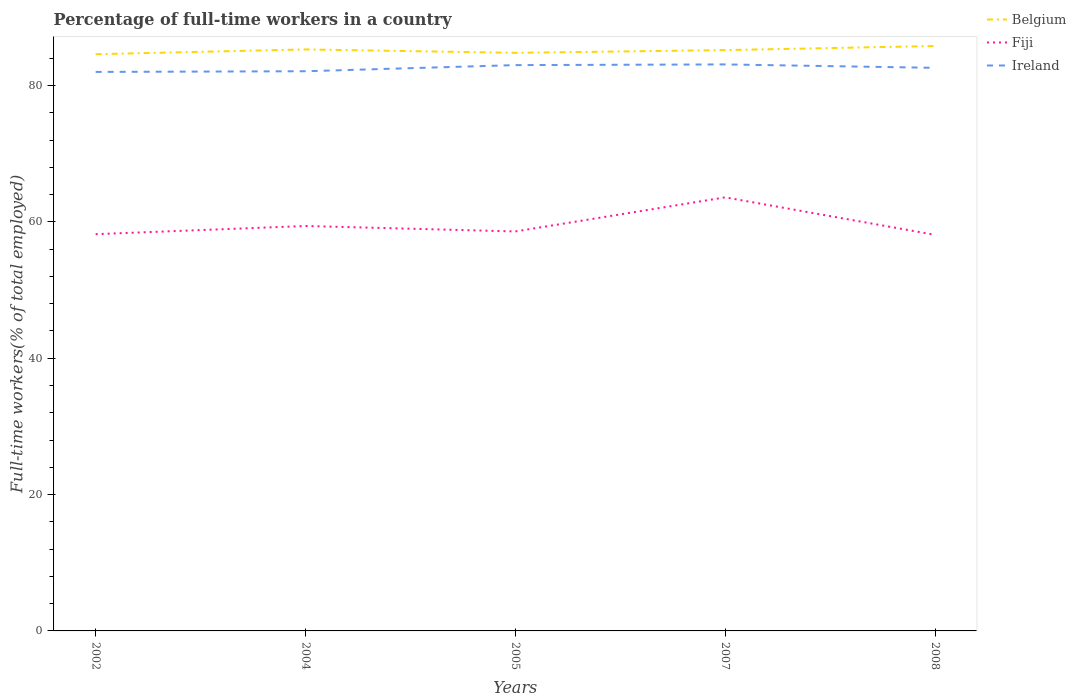Does the line corresponding to Ireland intersect with the line corresponding to Fiji?
Your answer should be very brief. No. Across all years, what is the maximum percentage of full-time workers in Fiji?
Provide a short and direct response. 58.1. In which year was the percentage of full-time workers in Fiji maximum?
Give a very brief answer. 2008. What is the total percentage of full-time workers in Ireland in the graph?
Offer a terse response. -0.6. What is the difference between the highest and the second highest percentage of full-time workers in Fiji?
Keep it short and to the point. 5.5. Is the percentage of full-time workers in Ireland strictly greater than the percentage of full-time workers in Belgium over the years?
Keep it short and to the point. Yes. What is the difference between two consecutive major ticks on the Y-axis?
Your answer should be very brief. 20. Are the values on the major ticks of Y-axis written in scientific E-notation?
Make the answer very short. No. Does the graph contain grids?
Offer a terse response. No. How many legend labels are there?
Make the answer very short. 3. What is the title of the graph?
Provide a succinct answer. Percentage of full-time workers in a country. What is the label or title of the Y-axis?
Your answer should be very brief. Full-time workers(% of total employed). What is the Full-time workers(% of total employed) in Belgium in 2002?
Ensure brevity in your answer.  84.6. What is the Full-time workers(% of total employed) of Fiji in 2002?
Ensure brevity in your answer.  58.2. What is the Full-time workers(% of total employed) in Belgium in 2004?
Your answer should be compact. 85.3. What is the Full-time workers(% of total employed) in Fiji in 2004?
Offer a very short reply. 59.4. What is the Full-time workers(% of total employed) of Ireland in 2004?
Provide a succinct answer. 82.1. What is the Full-time workers(% of total employed) of Belgium in 2005?
Provide a succinct answer. 84.8. What is the Full-time workers(% of total employed) of Fiji in 2005?
Keep it short and to the point. 58.6. What is the Full-time workers(% of total employed) in Belgium in 2007?
Provide a short and direct response. 85.2. What is the Full-time workers(% of total employed) of Fiji in 2007?
Your answer should be compact. 63.6. What is the Full-time workers(% of total employed) of Ireland in 2007?
Your response must be concise. 83.1. What is the Full-time workers(% of total employed) of Belgium in 2008?
Your response must be concise. 85.8. What is the Full-time workers(% of total employed) of Fiji in 2008?
Offer a very short reply. 58.1. What is the Full-time workers(% of total employed) in Ireland in 2008?
Provide a succinct answer. 82.6. Across all years, what is the maximum Full-time workers(% of total employed) of Belgium?
Keep it short and to the point. 85.8. Across all years, what is the maximum Full-time workers(% of total employed) of Fiji?
Offer a terse response. 63.6. Across all years, what is the maximum Full-time workers(% of total employed) in Ireland?
Provide a short and direct response. 83.1. Across all years, what is the minimum Full-time workers(% of total employed) in Belgium?
Keep it short and to the point. 84.6. Across all years, what is the minimum Full-time workers(% of total employed) in Fiji?
Ensure brevity in your answer.  58.1. Across all years, what is the minimum Full-time workers(% of total employed) in Ireland?
Offer a terse response. 82. What is the total Full-time workers(% of total employed) in Belgium in the graph?
Your answer should be compact. 425.7. What is the total Full-time workers(% of total employed) of Fiji in the graph?
Your answer should be compact. 297.9. What is the total Full-time workers(% of total employed) in Ireland in the graph?
Provide a succinct answer. 412.8. What is the difference between the Full-time workers(% of total employed) of Belgium in 2002 and that in 2004?
Offer a very short reply. -0.7. What is the difference between the Full-time workers(% of total employed) of Fiji in 2002 and that in 2004?
Offer a very short reply. -1.2. What is the difference between the Full-time workers(% of total employed) in Ireland in 2002 and that in 2004?
Provide a succinct answer. -0.1. What is the difference between the Full-time workers(% of total employed) of Belgium in 2002 and that in 2007?
Make the answer very short. -0.6. What is the difference between the Full-time workers(% of total employed) in Fiji in 2002 and that in 2007?
Your response must be concise. -5.4. What is the difference between the Full-time workers(% of total employed) of Belgium in 2002 and that in 2008?
Your answer should be compact. -1.2. What is the difference between the Full-time workers(% of total employed) of Belgium in 2004 and that in 2005?
Offer a very short reply. 0.5. What is the difference between the Full-time workers(% of total employed) of Ireland in 2004 and that in 2005?
Your response must be concise. -0.9. What is the difference between the Full-time workers(% of total employed) of Fiji in 2004 and that in 2007?
Keep it short and to the point. -4.2. What is the difference between the Full-time workers(% of total employed) in Belgium in 2005 and that in 2007?
Provide a succinct answer. -0.4. What is the difference between the Full-time workers(% of total employed) in Ireland in 2005 and that in 2007?
Offer a very short reply. -0.1. What is the difference between the Full-time workers(% of total employed) of Fiji in 2005 and that in 2008?
Give a very brief answer. 0.5. What is the difference between the Full-time workers(% of total employed) in Ireland in 2005 and that in 2008?
Make the answer very short. 0.4. What is the difference between the Full-time workers(% of total employed) in Belgium in 2007 and that in 2008?
Make the answer very short. -0.6. What is the difference between the Full-time workers(% of total employed) of Ireland in 2007 and that in 2008?
Provide a succinct answer. 0.5. What is the difference between the Full-time workers(% of total employed) of Belgium in 2002 and the Full-time workers(% of total employed) of Fiji in 2004?
Provide a succinct answer. 25.2. What is the difference between the Full-time workers(% of total employed) in Belgium in 2002 and the Full-time workers(% of total employed) in Ireland in 2004?
Your answer should be compact. 2.5. What is the difference between the Full-time workers(% of total employed) of Fiji in 2002 and the Full-time workers(% of total employed) of Ireland in 2004?
Offer a very short reply. -23.9. What is the difference between the Full-time workers(% of total employed) of Fiji in 2002 and the Full-time workers(% of total employed) of Ireland in 2005?
Offer a terse response. -24.8. What is the difference between the Full-time workers(% of total employed) of Fiji in 2002 and the Full-time workers(% of total employed) of Ireland in 2007?
Keep it short and to the point. -24.9. What is the difference between the Full-time workers(% of total employed) in Belgium in 2002 and the Full-time workers(% of total employed) in Fiji in 2008?
Make the answer very short. 26.5. What is the difference between the Full-time workers(% of total employed) in Belgium in 2002 and the Full-time workers(% of total employed) in Ireland in 2008?
Your answer should be very brief. 2. What is the difference between the Full-time workers(% of total employed) of Fiji in 2002 and the Full-time workers(% of total employed) of Ireland in 2008?
Your answer should be compact. -24.4. What is the difference between the Full-time workers(% of total employed) in Belgium in 2004 and the Full-time workers(% of total employed) in Fiji in 2005?
Make the answer very short. 26.7. What is the difference between the Full-time workers(% of total employed) in Belgium in 2004 and the Full-time workers(% of total employed) in Ireland in 2005?
Your answer should be compact. 2.3. What is the difference between the Full-time workers(% of total employed) in Fiji in 2004 and the Full-time workers(% of total employed) in Ireland in 2005?
Your response must be concise. -23.6. What is the difference between the Full-time workers(% of total employed) of Belgium in 2004 and the Full-time workers(% of total employed) of Fiji in 2007?
Your answer should be very brief. 21.7. What is the difference between the Full-time workers(% of total employed) in Belgium in 2004 and the Full-time workers(% of total employed) in Ireland in 2007?
Make the answer very short. 2.2. What is the difference between the Full-time workers(% of total employed) of Fiji in 2004 and the Full-time workers(% of total employed) of Ireland in 2007?
Your response must be concise. -23.7. What is the difference between the Full-time workers(% of total employed) of Belgium in 2004 and the Full-time workers(% of total employed) of Fiji in 2008?
Provide a short and direct response. 27.2. What is the difference between the Full-time workers(% of total employed) of Fiji in 2004 and the Full-time workers(% of total employed) of Ireland in 2008?
Ensure brevity in your answer.  -23.2. What is the difference between the Full-time workers(% of total employed) of Belgium in 2005 and the Full-time workers(% of total employed) of Fiji in 2007?
Provide a short and direct response. 21.2. What is the difference between the Full-time workers(% of total employed) in Belgium in 2005 and the Full-time workers(% of total employed) in Ireland in 2007?
Provide a short and direct response. 1.7. What is the difference between the Full-time workers(% of total employed) of Fiji in 2005 and the Full-time workers(% of total employed) of Ireland in 2007?
Your answer should be very brief. -24.5. What is the difference between the Full-time workers(% of total employed) in Belgium in 2005 and the Full-time workers(% of total employed) in Fiji in 2008?
Your answer should be very brief. 26.7. What is the difference between the Full-time workers(% of total employed) of Belgium in 2005 and the Full-time workers(% of total employed) of Ireland in 2008?
Provide a succinct answer. 2.2. What is the difference between the Full-time workers(% of total employed) in Belgium in 2007 and the Full-time workers(% of total employed) in Fiji in 2008?
Provide a short and direct response. 27.1. What is the difference between the Full-time workers(% of total employed) of Belgium in 2007 and the Full-time workers(% of total employed) of Ireland in 2008?
Ensure brevity in your answer.  2.6. What is the difference between the Full-time workers(% of total employed) of Fiji in 2007 and the Full-time workers(% of total employed) of Ireland in 2008?
Your answer should be compact. -19. What is the average Full-time workers(% of total employed) in Belgium per year?
Your response must be concise. 85.14. What is the average Full-time workers(% of total employed) of Fiji per year?
Give a very brief answer. 59.58. What is the average Full-time workers(% of total employed) in Ireland per year?
Make the answer very short. 82.56. In the year 2002, what is the difference between the Full-time workers(% of total employed) of Belgium and Full-time workers(% of total employed) of Fiji?
Provide a short and direct response. 26.4. In the year 2002, what is the difference between the Full-time workers(% of total employed) in Belgium and Full-time workers(% of total employed) in Ireland?
Your answer should be compact. 2.6. In the year 2002, what is the difference between the Full-time workers(% of total employed) of Fiji and Full-time workers(% of total employed) of Ireland?
Your answer should be compact. -23.8. In the year 2004, what is the difference between the Full-time workers(% of total employed) of Belgium and Full-time workers(% of total employed) of Fiji?
Your answer should be compact. 25.9. In the year 2004, what is the difference between the Full-time workers(% of total employed) of Belgium and Full-time workers(% of total employed) of Ireland?
Your answer should be very brief. 3.2. In the year 2004, what is the difference between the Full-time workers(% of total employed) of Fiji and Full-time workers(% of total employed) of Ireland?
Offer a terse response. -22.7. In the year 2005, what is the difference between the Full-time workers(% of total employed) in Belgium and Full-time workers(% of total employed) in Fiji?
Provide a short and direct response. 26.2. In the year 2005, what is the difference between the Full-time workers(% of total employed) of Fiji and Full-time workers(% of total employed) of Ireland?
Give a very brief answer. -24.4. In the year 2007, what is the difference between the Full-time workers(% of total employed) of Belgium and Full-time workers(% of total employed) of Fiji?
Keep it short and to the point. 21.6. In the year 2007, what is the difference between the Full-time workers(% of total employed) of Belgium and Full-time workers(% of total employed) of Ireland?
Provide a succinct answer. 2.1. In the year 2007, what is the difference between the Full-time workers(% of total employed) in Fiji and Full-time workers(% of total employed) in Ireland?
Offer a terse response. -19.5. In the year 2008, what is the difference between the Full-time workers(% of total employed) of Belgium and Full-time workers(% of total employed) of Fiji?
Your answer should be compact. 27.7. In the year 2008, what is the difference between the Full-time workers(% of total employed) in Belgium and Full-time workers(% of total employed) in Ireland?
Your answer should be compact. 3.2. In the year 2008, what is the difference between the Full-time workers(% of total employed) of Fiji and Full-time workers(% of total employed) of Ireland?
Make the answer very short. -24.5. What is the ratio of the Full-time workers(% of total employed) of Belgium in 2002 to that in 2004?
Make the answer very short. 0.99. What is the ratio of the Full-time workers(% of total employed) in Fiji in 2002 to that in 2004?
Keep it short and to the point. 0.98. What is the ratio of the Full-time workers(% of total employed) in Belgium in 2002 to that in 2005?
Offer a very short reply. 1. What is the ratio of the Full-time workers(% of total employed) of Belgium in 2002 to that in 2007?
Ensure brevity in your answer.  0.99. What is the ratio of the Full-time workers(% of total employed) of Fiji in 2002 to that in 2007?
Your response must be concise. 0.92. What is the ratio of the Full-time workers(% of total employed) of Ireland in 2002 to that in 2007?
Your answer should be very brief. 0.99. What is the ratio of the Full-time workers(% of total employed) in Belgium in 2004 to that in 2005?
Your response must be concise. 1.01. What is the ratio of the Full-time workers(% of total employed) of Fiji in 2004 to that in 2005?
Ensure brevity in your answer.  1.01. What is the ratio of the Full-time workers(% of total employed) of Ireland in 2004 to that in 2005?
Your answer should be compact. 0.99. What is the ratio of the Full-time workers(% of total employed) of Fiji in 2004 to that in 2007?
Make the answer very short. 0.93. What is the ratio of the Full-time workers(% of total employed) of Ireland in 2004 to that in 2007?
Your answer should be very brief. 0.99. What is the ratio of the Full-time workers(% of total employed) in Belgium in 2004 to that in 2008?
Give a very brief answer. 0.99. What is the ratio of the Full-time workers(% of total employed) of Fiji in 2004 to that in 2008?
Offer a terse response. 1.02. What is the ratio of the Full-time workers(% of total employed) in Fiji in 2005 to that in 2007?
Provide a succinct answer. 0.92. What is the ratio of the Full-time workers(% of total employed) in Belgium in 2005 to that in 2008?
Ensure brevity in your answer.  0.99. What is the ratio of the Full-time workers(% of total employed) in Fiji in 2005 to that in 2008?
Provide a succinct answer. 1.01. What is the ratio of the Full-time workers(% of total employed) of Ireland in 2005 to that in 2008?
Your response must be concise. 1. What is the ratio of the Full-time workers(% of total employed) of Belgium in 2007 to that in 2008?
Offer a very short reply. 0.99. What is the ratio of the Full-time workers(% of total employed) of Fiji in 2007 to that in 2008?
Make the answer very short. 1.09. 